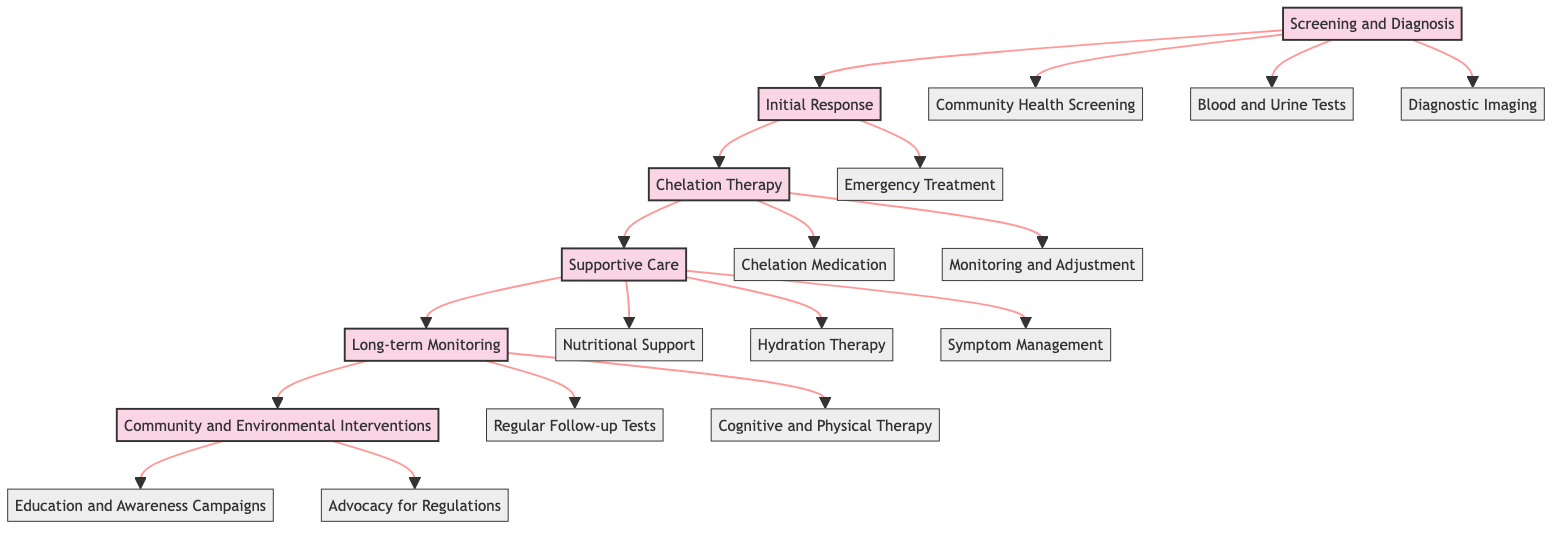What is the first stage in the clinical pathway? The diagram indicates the first stage as "Screening and Diagnosis," which is the initial phase where actions related to identifying heavy metal exposure take place.
Answer: Screening and Diagnosis How many actions are listed under the "Supportive Care" stage? The "Supportive Care" stage includes three actions: Nutritional Support, Hydration Therapy, and Symptom Management, which are all aimed at providing supportive interventions for those affected by heavy metal poisoning.
Answer: Three What type of therapy is administered in the "Chelation Therapy" stage? Under the "Chelation Therapy" stage, the type of therapy administered is "Chelation Medication," which involves using specific agents to bind heavy metals and facilitate their excretion from the body.
Answer: Chelation Medication What action follows the "Initial Response" stage? The "Chelation Therapy" stage follows directly after "Initial Response," indicating a sequential process where immediate care leads into a more specialized treatment for heavy metal poisoning.
Answer: Chelation Therapy What is the purpose of the "Community and Environmental Interventions" stage? The purpose of the "Community and Environmental Interventions" stage is to conduct actions like Education and Awareness Campaigns and Advocacy for Regulations, aimed at reducing heavy metal exposure in mining regions through community engagement and policy advocacy.
Answer: Education and Awareness Campaigns Which stage includes "Monitoring and Adjustment"? The "Monitoring and Adjustment" action is part of the "Chelation Therapy" stage, indicating that this step focuses on the ongoing evaluation and modification of treatment based on the patient’s condition and vital signs.
Answer: Chelation Therapy What is the last action listed in the diagram? The last action listed in the diagram is "Advocacy for Regulations," which emphasizes the importance of community action and policy change to mitigate heavy metal pollution from mining activities.
Answer: Advocacy for Regulations How many total main stages are represented in the diagram? The diagram features a total of six main stages: Screening and Diagnosis, Initial Response, Chelation Therapy, Supportive Care, Long-term Monitoring, and Community and Environmental Interventions, reflecting a comprehensive approach to treatment and prevention.
Answer: Six 